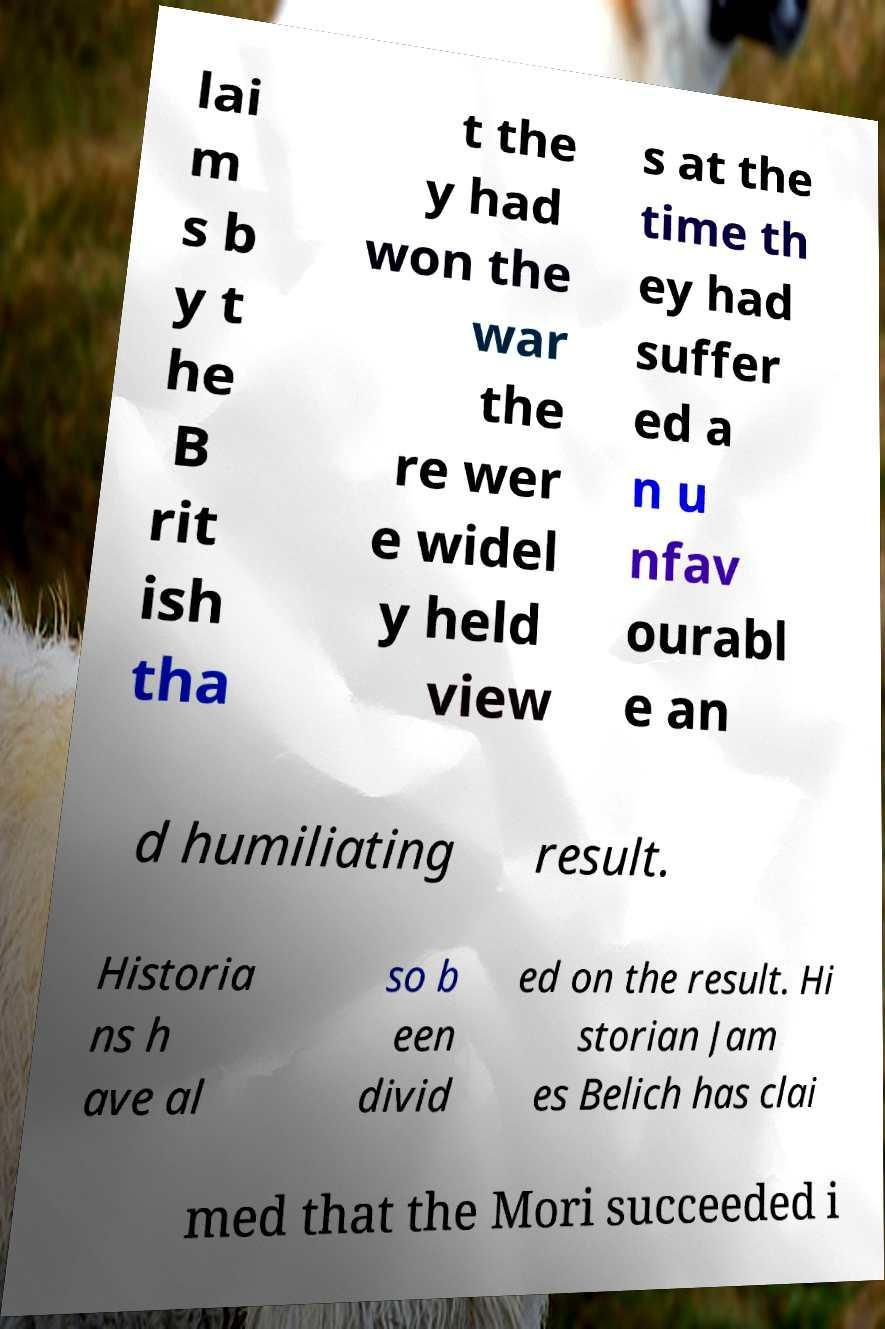I need the written content from this picture converted into text. Can you do that? lai m s b y t he B rit ish tha t the y had won the war the re wer e widel y held view s at the time th ey had suffer ed a n u nfav ourabl e an d humiliating result. Historia ns h ave al so b een divid ed on the result. Hi storian Jam es Belich has clai med that the Mori succeeded i 